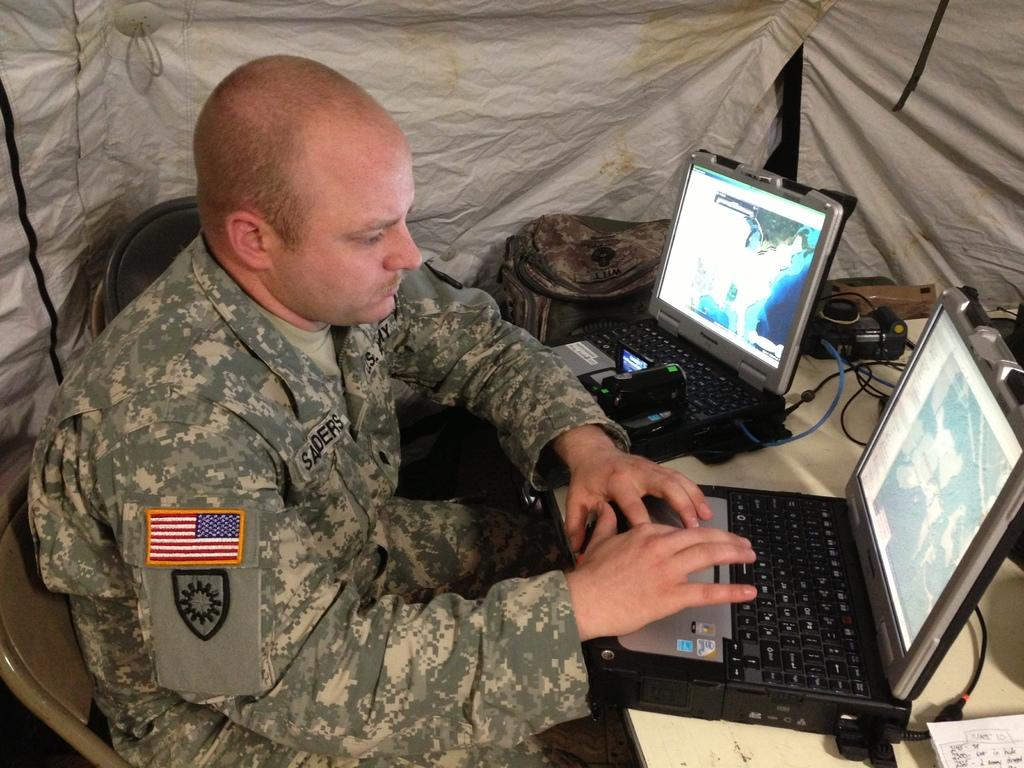Provide a one-sentence caption for the provided image. Name of the American soldier is Saders and he is typing. 